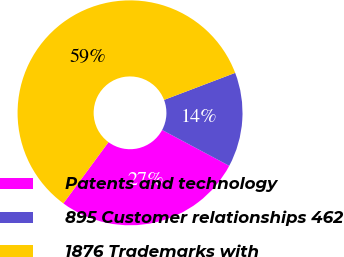Convert chart to OTSL. <chart><loc_0><loc_0><loc_500><loc_500><pie_chart><fcel>Patents and technology<fcel>895 Customer relationships 462<fcel>1876 Trademarks with<nl><fcel>27.29%<fcel>13.59%<fcel>59.12%<nl></chart> 